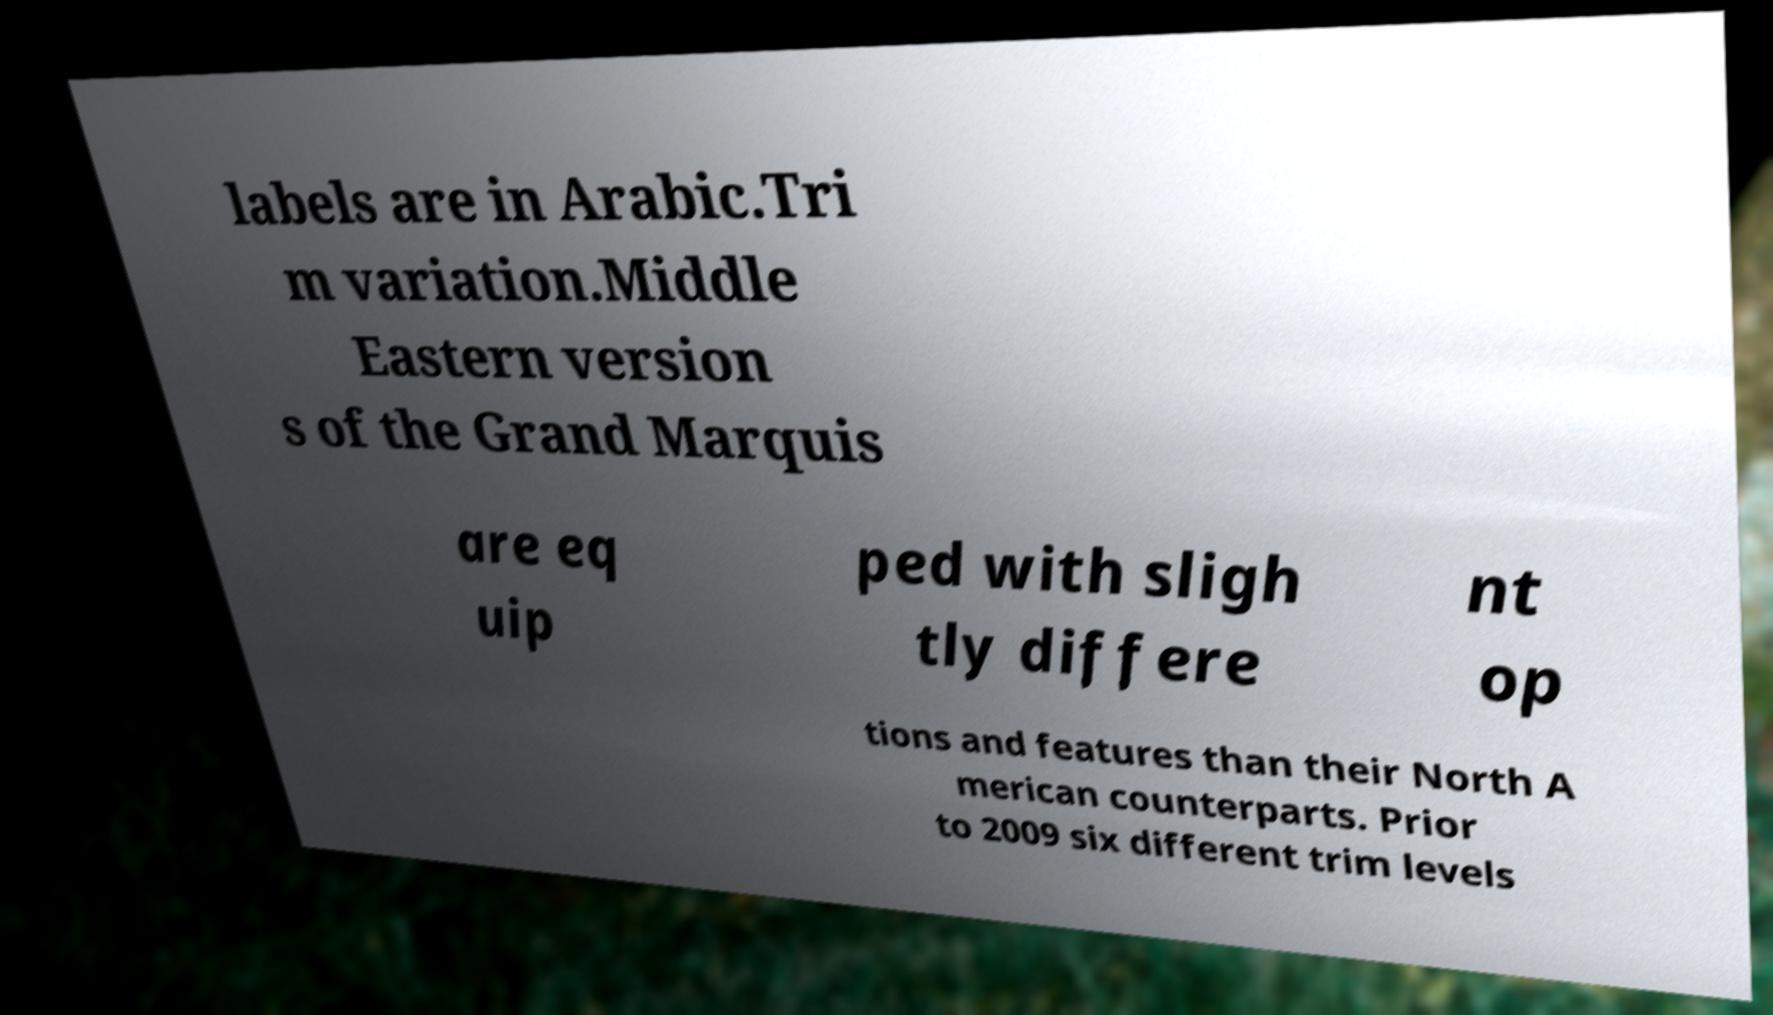Could you extract and type out the text from this image? labels are in Arabic.Tri m variation.Middle Eastern version s of the Grand Marquis are eq uip ped with sligh tly differe nt op tions and features than their North A merican counterparts. Prior to 2009 six different trim levels 